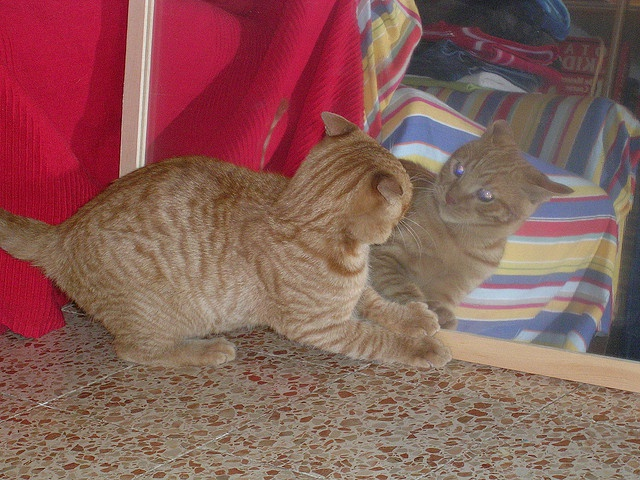Describe the objects in this image and their specific colors. I can see cat in brown and gray tones and book in brown, gray, and maroon tones in this image. 